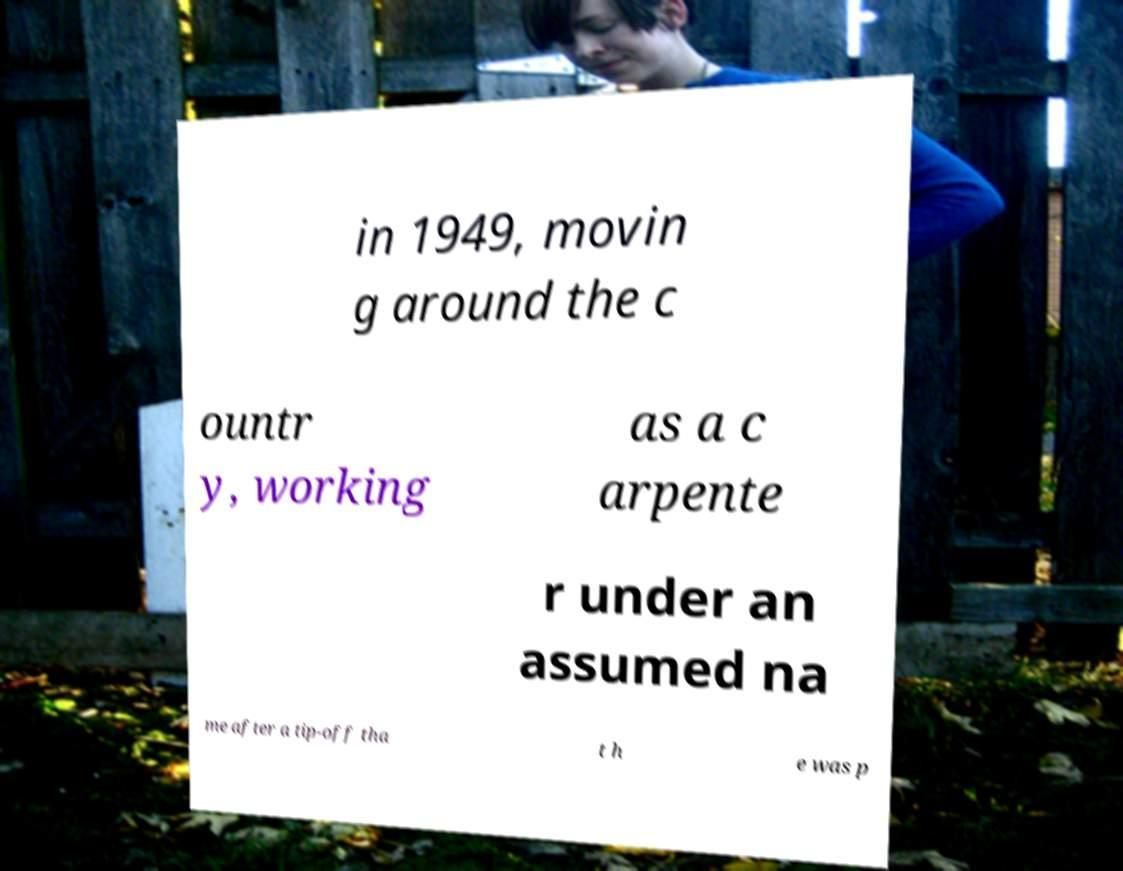For documentation purposes, I need the text within this image transcribed. Could you provide that? in 1949, movin g around the c ountr y, working as a c arpente r under an assumed na me after a tip-off tha t h e was p 